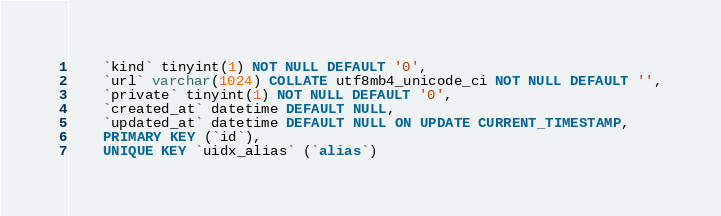Convert code to text. <code><loc_0><loc_0><loc_500><loc_500><_SQL_>    `kind` tinyint(1) NOT NULL DEFAULT '0',
    `url` varchar(1024) COLLATE utf8mb4_unicode_ci NOT NULL DEFAULT '',
    `private` tinyint(1) NOT NULL DEFAULT '0',
    `created_at` datetime DEFAULT NULL,
    `updated_at` datetime DEFAULT NULL ON UPDATE CURRENT_TIMESTAMP,
    PRIMARY KEY (`id`),
    UNIQUE KEY `uidx_alias` (`alias`)</code> 